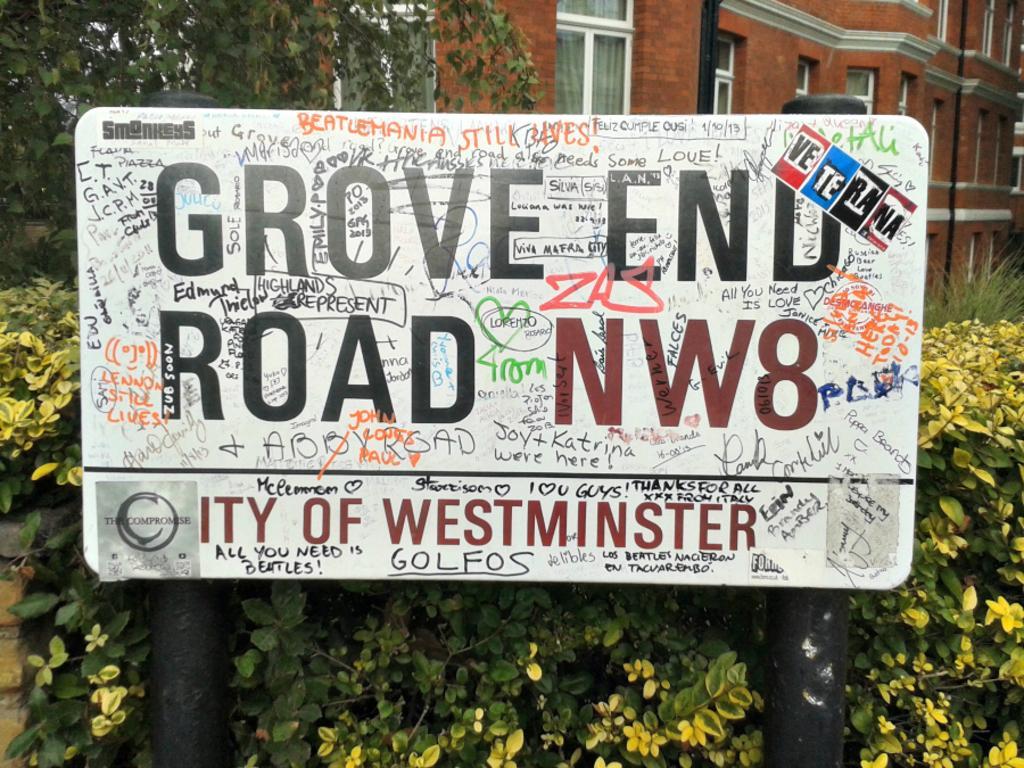Could you give a brief overview of what you see in this image? Here in this picture we can see a board present over there and we can see something written on it all over there and behind it we can see plants and trees present all over there and we can see building also present over there with windows on it. 